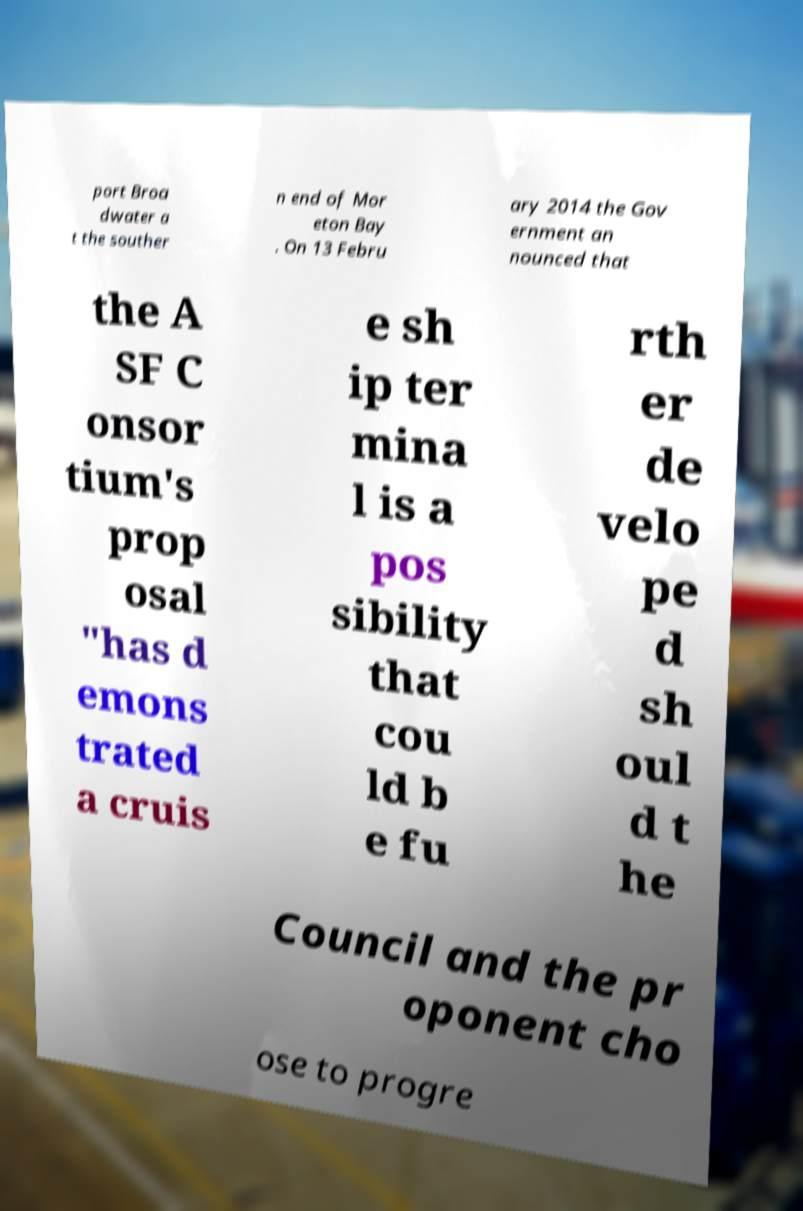Could you assist in decoding the text presented in this image and type it out clearly? port Broa dwater a t the souther n end of Mor eton Bay . On 13 Febru ary 2014 the Gov ernment an nounced that the A SF C onsor tium's prop osal "has d emons trated a cruis e sh ip ter mina l is a pos sibility that cou ld b e fu rth er de velo pe d sh oul d t he Council and the pr oponent cho ose to progre 